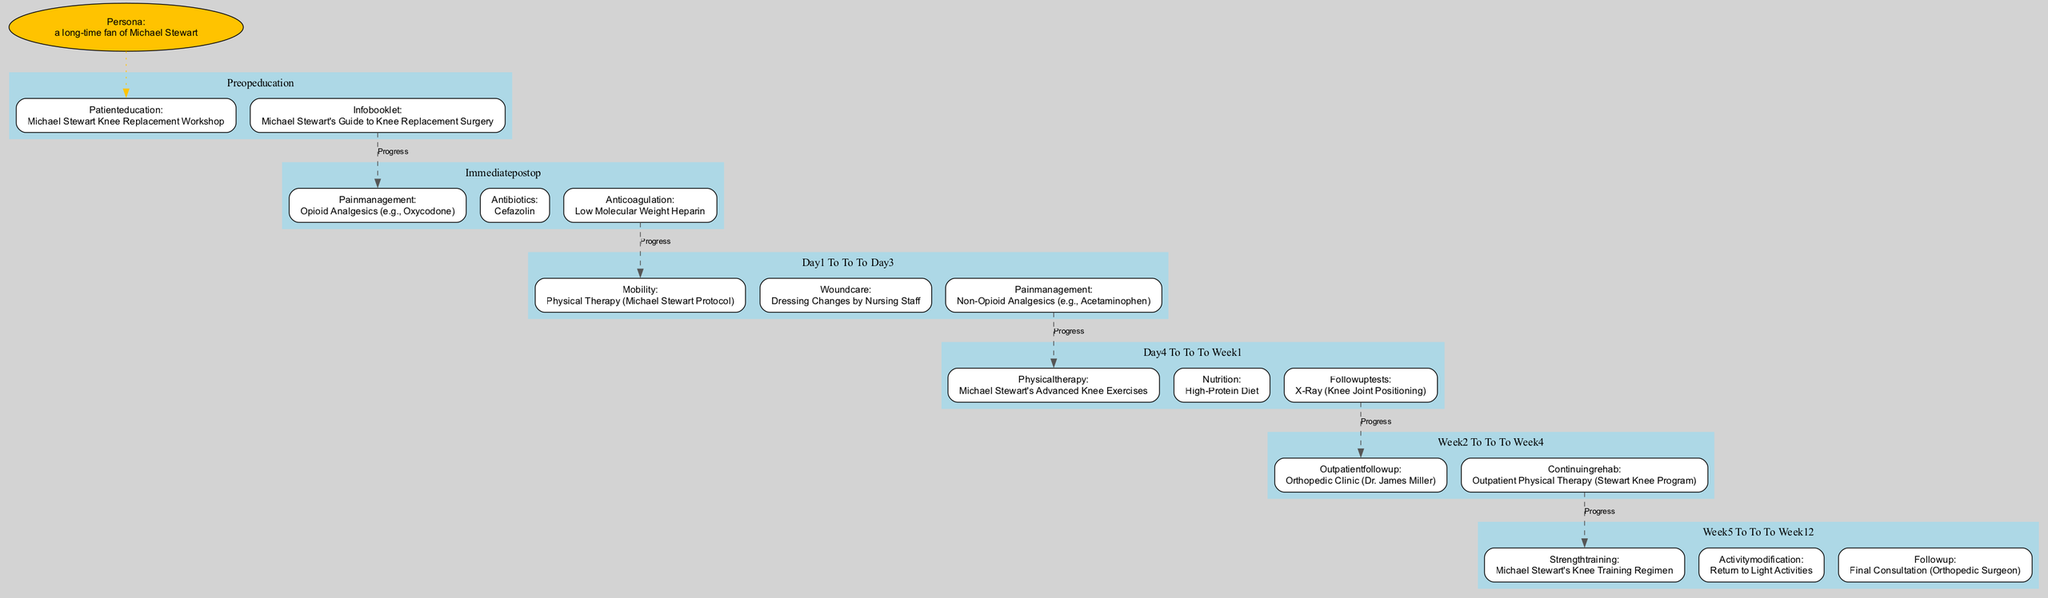What is the patient education workshop called? The diagram indicates that the patient education workshop is named "Michael Stewart Knee Replacement Workshop." This information is found in the "preOpEducation" section of the pathway.
Answer: Michael Stewart Knee Replacement Workshop What type of antibiotics is administered immediately post-operation? According to the "immediatePostOp" section of the diagram, the antibiotic specified is "Cefazolin." This directly addresses the antibiotic administration at this stage.
Answer: Cefazolin What physical therapy protocol is recommended on Day 1 to Day 3? The diagram indicates that the recommended physical therapy during Day 1 to Day 3 is the "Michael Stewart Protocol." This information is gathered from the "day1_to_day3" section.
Answer: Michael Stewart Protocol How long is the outpatient follow-up scheduled after surgery? The diagram indicates that the outpatient follow-up occurs "week2_to_week4." This specifies the timeframe for the follow-up after the surgery.
Answer: Week 2 to Week 4 What type of diet is recommended during Day 4 to Week 1? Within the "day4_to_week1" section, the recommended diet is a "High-Protein Diet." This is found under the nutrition aspect of that timeframe.
Answer: High-Protein Diet Which program is associated with continuing rehab in the weeks following the surgery? The "week2_to_week4" section states that the continuing rehabilitation program is "Outpatient Physical Therapy (Stewart Knee Program)." This links the program to the rehab phase after surgery.
Answer: Outpatient Physical Therapy (Stewart Knee Program) What type of management is recommended for pain during Day 1 to Day 3? The diagram specifies "Non-Opioid Analgesics (e.g., Acetaminophen)" for pain management in the "day1_to_day3" section. This direct quote provides the required information.
Answer: Non-Opioid Analgesics (e.g., Acetaminophen) What is the final step before completion of the pathway? The "week5_to_week12" section outlines the final step as "Final Consultation (Orthopedic Surgeon)." This is the concluding stage of the pathway.
Answer: Final Consultation (Orthopedic Surgeon) 